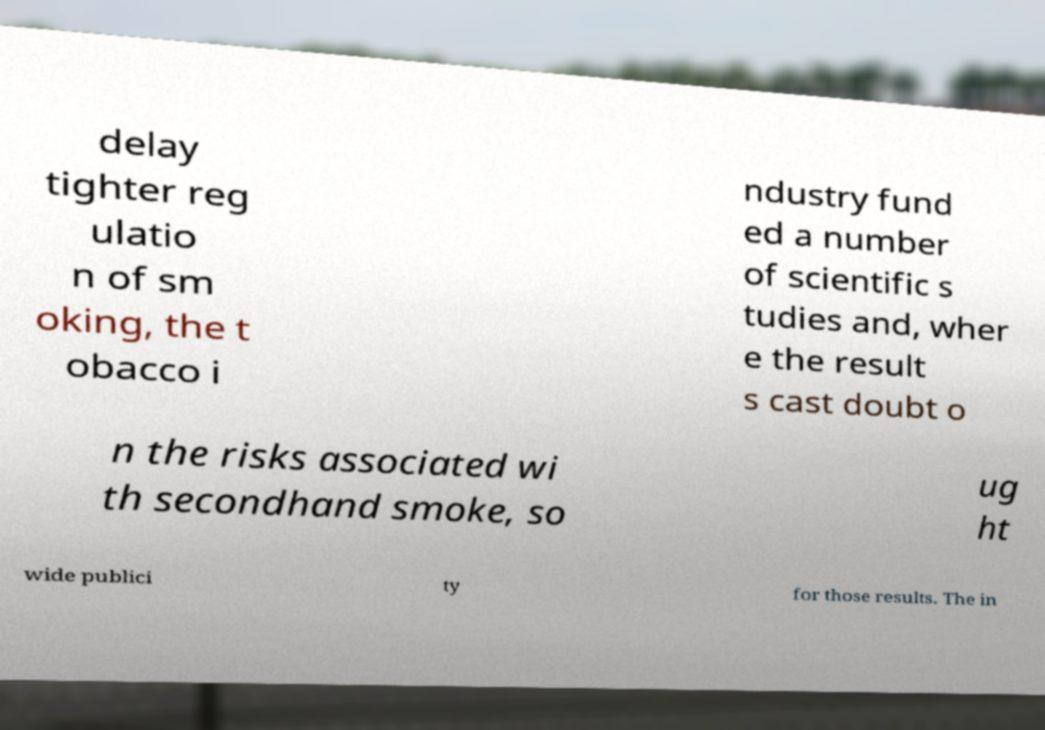There's text embedded in this image that I need extracted. Can you transcribe it verbatim? delay tighter reg ulatio n of sm oking, the t obacco i ndustry fund ed a number of scientific s tudies and, wher e the result s cast doubt o n the risks associated wi th secondhand smoke, so ug ht wide publici ty for those results. The in 